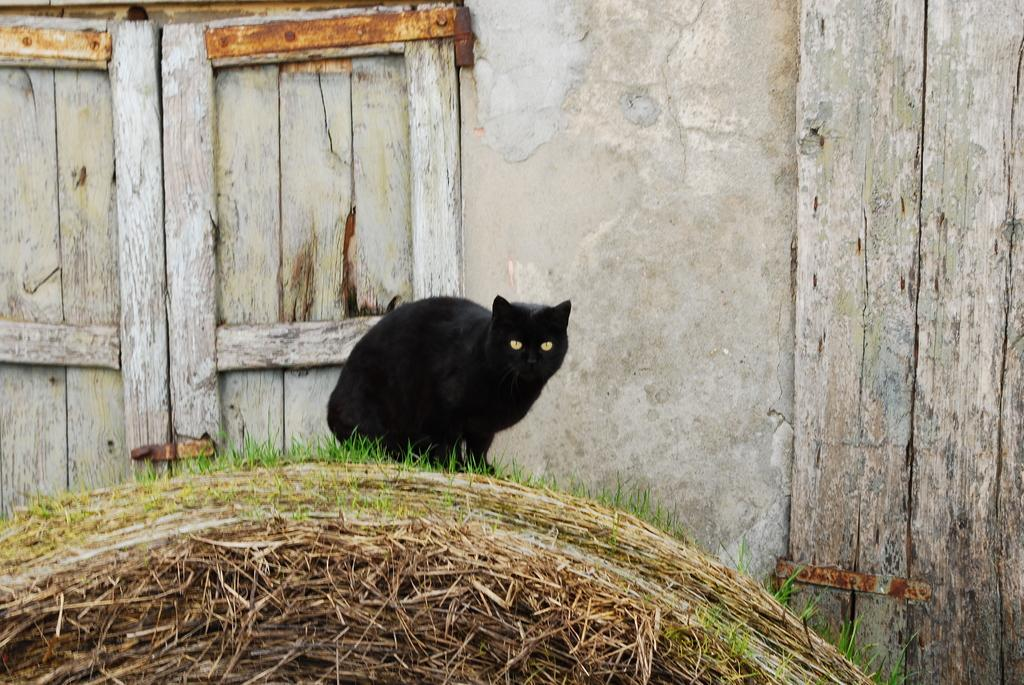What animal is present in the image? There is a cat in the image. Where is the cat located? The cat is on the grass. What can be seen in the background of the image? There is a building in the background of the image. What type of doors does the building have? The building has wooden doors. What is the weight of the cat in the image? The weight of the cat cannot be determined from the image alone. --- 